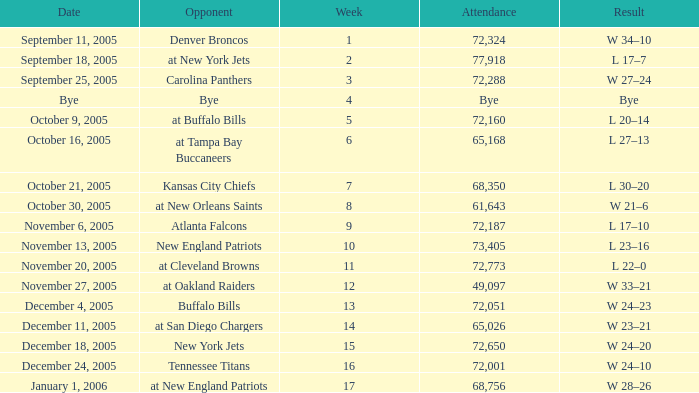I'm looking to parse the entire table for insights. Could you assist me with that? {'header': ['Date', 'Opponent', 'Week', 'Attendance', 'Result'], 'rows': [['September 11, 2005', 'Denver Broncos', '1', '72,324', 'W 34–10'], ['September 18, 2005', 'at New York Jets', '2', '77,918', 'L 17–7'], ['September 25, 2005', 'Carolina Panthers', '3', '72,288', 'W 27–24'], ['Bye', 'Bye', '4', 'Bye', 'Bye'], ['October 9, 2005', 'at Buffalo Bills', '5', '72,160', 'L 20–14'], ['October 16, 2005', 'at Tampa Bay Buccaneers', '6', '65,168', 'L 27–13'], ['October 21, 2005', 'Kansas City Chiefs', '7', '68,350', 'L 30–20'], ['October 30, 2005', 'at New Orleans Saints', '8', '61,643', 'W 21–6'], ['November 6, 2005', 'Atlanta Falcons', '9', '72,187', 'L 17–10'], ['November 13, 2005', 'New England Patriots', '10', '73,405', 'L 23–16'], ['November 20, 2005', 'at Cleveland Browns', '11', '72,773', 'L 22–0'], ['November 27, 2005', 'at Oakland Raiders', '12', '49,097', 'W 33–21'], ['December 4, 2005', 'Buffalo Bills', '13', '72,051', 'W 24–23'], ['December 11, 2005', 'at San Diego Chargers', '14', '65,026', 'W 23–21'], ['December 18, 2005', 'New York Jets', '15', '72,650', 'W 24–20'], ['December 24, 2005', 'Tennessee Titans', '16', '72,001', 'W 24–10'], ['January 1, 2006', 'at New England Patriots', '17', '68,756', 'W 28–26']]} What is the Date of the game with an attendance of 72,051 after Week 9? December 4, 2005. 